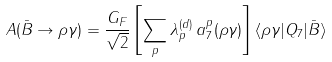<formula> <loc_0><loc_0><loc_500><loc_500>A ( \bar { B } \to \rho \gamma ) = \frac { G _ { F } } { \sqrt { 2 } } \left [ \sum _ { p } \lambda _ { p } ^ { ( d ) } \, a ^ { p } _ { 7 } ( \rho \gamma ) \right ] \langle \rho \gamma | Q _ { 7 } | \bar { B } \rangle</formula> 